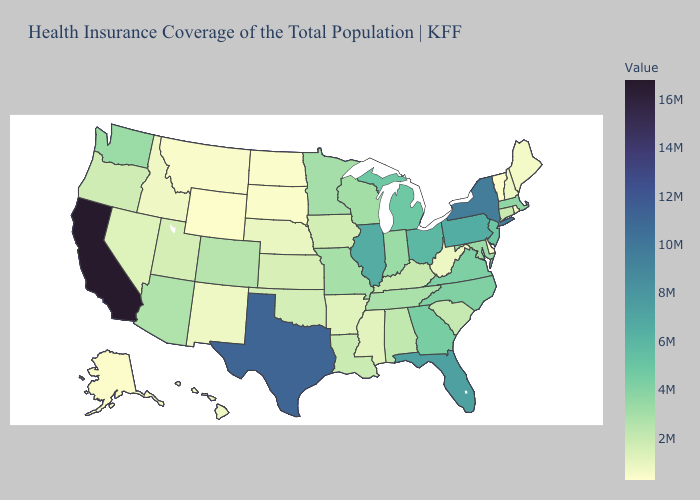Does California have the highest value in the USA?
Be succinct. Yes. Among the states that border Oklahoma , which have the highest value?
Be succinct. Texas. Does North Dakota have the lowest value in the MidWest?
Be succinct. Yes. Does the map have missing data?
Concise answer only. No. Which states have the lowest value in the USA?
Answer briefly. Wyoming. Among the states that border Idaho , which have the highest value?
Concise answer only. Washington. Which states have the lowest value in the USA?
Give a very brief answer. Wyoming. 